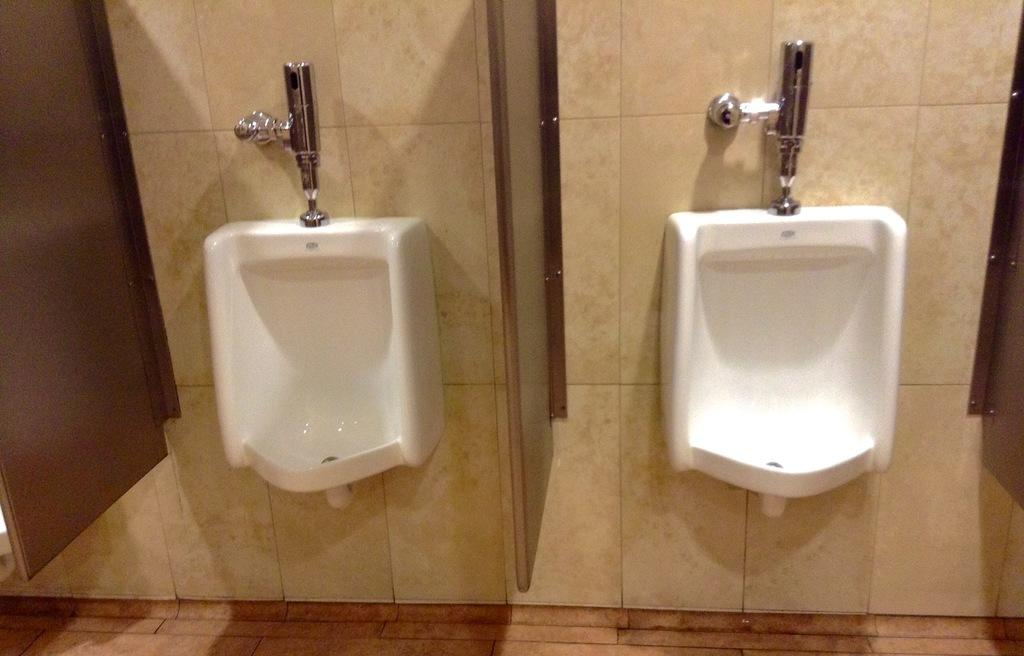What type of fixtures are present in the image? There are two white toilets in the image. What is used to flush the toilets in the image? There are two flushes attached to the wall in the image. What color is the wall in the image? The wall is in cream color. What type of trouble is the uncle experiencing with his chin in the image? There is no uncle or chin present in the image; it features two white toilets and two flushes attached to the wall. 